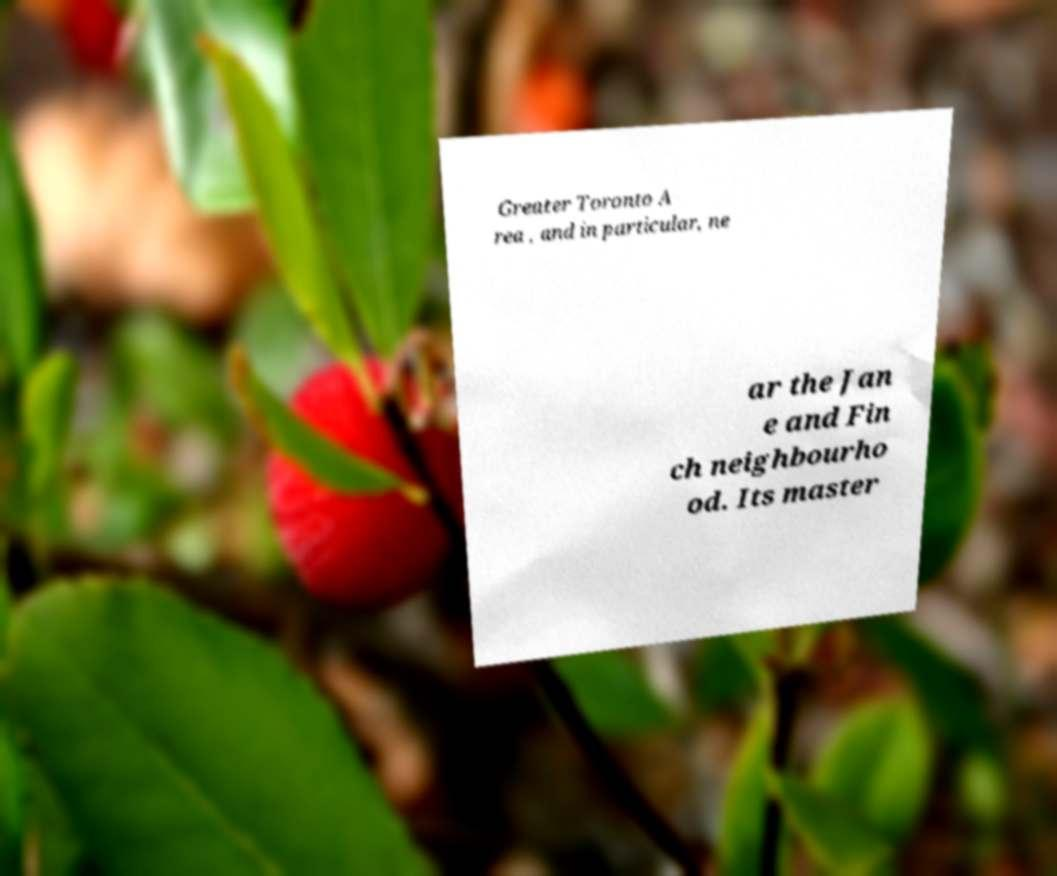What messages or text are displayed in this image? I need them in a readable, typed format. Greater Toronto A rea , and in particular, ne ar the Jan e and Fin ch neighbourho od. Its master 